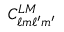Convert formula to latex. <formula><loc_0><loc_0><loc_500><loc_500>C _ { \ell m \ell ^ { \prime } m ^ { \prime } } ^ { L M }</formula> 